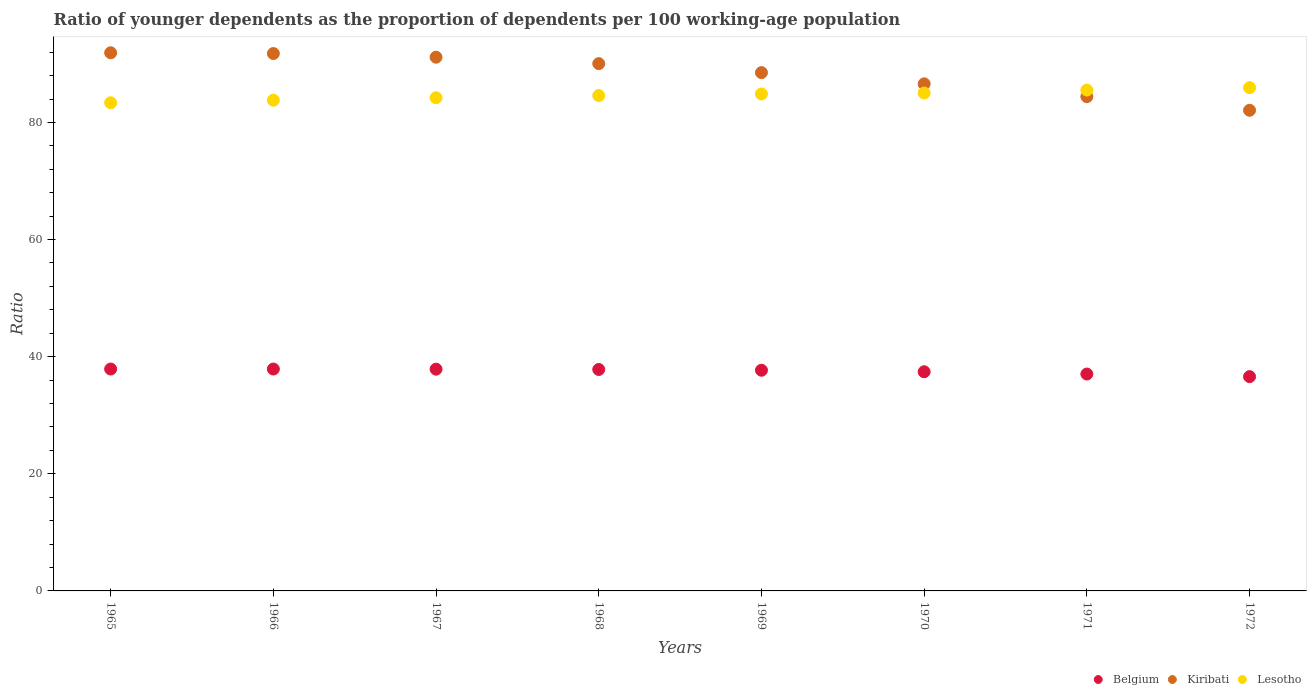What is the age dependency ratio(young) in Lesotho in 1965?
Give a very brief answer. 83.36. Across all years, what is the maximum age dependency ratio(young) in Belgium?
Offer a very short reply. 37.89. Across all years, what is the minimum age dependency ratio(young) in Kiribati?
Offer a very short reply. 82.08. In which year was the age dependency ratio(young) in Belgium maximum?
Give a very brief answer. 1966. In which year was the age dependency ratio(young) in Lesotho minimum?
Provide a short and direct response. 1965. What is the total age dependency ratio(young) in Lesotho in the graph?
Give a very brief answer. 677.34. What is the difference between the age dependency ratio(young) in Lesotho in 1966 and that in 1968?
Provide a short and direct response. -0.79. What is the difference between the age dependency ratio(young) in Belgium in 1966 and the age dependency ratio(young) in Kiribati in 1972?
Give a very brief answer. -44.19. What is the average age dependency ratio(young) in Belgium per year?
Your answer should be very brief. 37.53. In the year 1966, what is the difference between the age dependency ratio(young) in Lesotho and age dependency ratio(young) in Kiribati?
Your answer should be very brief. -7.97. In how many years, is the age dependency ratio(young) in Lesotho greater than 56?
Give a very brief answer. 8. What is the ratio of the age dependency ratio(young) in Kiribati in 1969 to that in 1971?
Your response must be concise. 1.05. Is the difference between the age dependency ratio(young) in Lesotho in 1966 and 1972 greater than the difference between the age dependency ratio(young) in Kiribati in 1966 and 1972?
Ensure brevity in your answer.  No. What is the difference between the highest and the second highest age dependency ratio(young) in Kiribati?
Provide a succinct answer. 0.13. What is the difference between the highest and the lowest age dependency ratio(young) in Kiribati?
Offer a terse response. 9.82. In how many years, is the age dependency ratio(young) in Lesotho greater than the average age dependency ratio(young) in Lesotho taken over all years?
Your answer should be compact. 4. Is the sum of the age dependency ratio(young) in Kiribati in 1967 and 1970 greater than the maximum age dependency ratio(young) in Lesotho across all years?
Provide a short and direct response. Yes. Is it the case that in every year, the sum of the age dependency ratio(young) in Belgium and age dependency ratio(young) in Kiribati  is greater than the age dependency ratio(young) in Lesotho?
Provide a succinct answer. Yes. Is the age dependency ratio(young) in Belgium strictly less than the age dependency ratio(young) in Kiribati over the years?
Ensure brevity in your answer.  Yes. How many years are there in the graph?
Ensure brevity in your answer.  8. What is the difference between two consecutive major ticks on the Y-axis?
Keep it short and to the point. 20. Are the values on the major ticks of Y-axis written in scientific E-notation?
Provide a succinct answer. No. Does the graph contain any zero values?
Your response must be concise. No. How many legend labels are there?
Provide a succinct answer. 3. How are the legend labels stacked?
Your answer should be compact. Horizontal. What is the title of the graph?
Your response must be concise. Ratio of younger dependents as the proportion of dependents per 100 working-age population. What is the label or title of the X-axis?
Offer a terse response. Years. What is the label or title of the Y-axis?
Your response must be concise. Ratio. What is the Ratio of Belgium in 1965?
Provide a succinct answer. 37.89. What is the Ratio of Kiribati in 1965?
Your answer should be compact. 91.9. What is the Ratio in Lesotho in 1965?
Ensure brevity in your answer.  83.36. What is the Ratio in Belgium in 1966?
Make the answer very short. 37.89. What is the Ratio of Kiribati in 1966?
Give a very brief answer. 91.77. What is the Ratio in Lesotho in 1966?
Provide a succinct answer. 83.8. What is the Ratio of Belgium in 1967?
Give a very brief answer. 37.87. What is the Ratio of Kiribati in 1967?
Make the answer very short. 91.14. What is the Ratio of Lesotho in 1967?
Provide a succinct answer. 84.22. What is the Ratio of Belgium in 1968?
Your response must be concise. 37.82. What is the Ratio in Kiribati in 1968?
Offer a very short reply. 90.04. What is the Ratio of Lesotho in 1968?
Give a very brief answer. 84.59. What is the Ratio in Belgium in 1969?
Give a very brief answer. 37.68. What is the Ratio of Kiribati in 1969?
Make the answer very short. 88.51. What is the Ratio in Lesotho in 1969?
Offer a terse response. 84.87. What is the Ratio of Belgium in 1970?
Give a very brief answer. 37.43. What is the Ratio of Kiribati in 1970?
Offer a terse response. 86.59. What is the Ratio of Lesotho in 1970?
Ensure brevity in your answer.  85.03. What is the Ratio of Belgium in 1971?
Offer a very short reply. 37.04. What is the Ratio of Kiribati in 1971?
Your answer should be very brief. 84.41. What is the Ratio in Lesotho in 1971?
Offer a terse response. 85.53. What is the Ratio of Belgium in 1972?
Ensure brevity in your answer.  36.59. What is the Ratio in Kiribati in 1972?
Offer a very short reply. 82.08. What is the Ratio of Lesotho in 1972?
Keep it short and to the point. 85.94. Across all years, what is the maximum Ratio in Belgium?
Your answer should be compact. 37.89. Across all years, what is the maximum Ratio of Kiribati?
Your answer should be very brief. 91.9. Across all years, what is the maximum Ratio of Lesotho?
Your answer should be very brief. 85.94. Across all years, what is the minimum Ratio in Belgium?
Keep it short and to the point. 36.59. Across all years, what is the minimum Ratio of Kiribati?
Keep it short and to the point. 82.08. Across all years, what is the minimum Ratio in Lesotho?
Your answer should be compact. 83.36. What is the total Ratio of Belgium in the graph?
Give a very brief answer. 300.2. What is the total Ratio of Kiribati in the graph?
Make the answer very short. 706.45. What is the total Ratio in Lesotho in the graph?
Make the answer very short. 677.34. What is the difference between the Ratio in Belgium in 1965 and that in 1966?
Your answer should be very brief. -0. What is the difference between the Ratio in Kiribati in 1965 and that in 1966?
Your answer should be very brief. 0.13. What is the difference between the Ratio in Lesotho in 1965 and that in 1966?
Offer a terse response. -0.44. What is the difference between the Ratio in Belgium in 1965 and that in 1967?
Your response must be concise. 0.02. What is the difference between the Ratio of Kiribati in 1965 and that in 1967?
Ensure brevity in your answer.  0.76. What is the difference between the Ratio in Lesotho in 1965 and that in 1967?
Your answer should be compact. -0.86. What is the difference between the Ratio of Belgium in 1965 and that in 1968?
Keep it short and to the point. 0.07. What is the difference between the Ratio of Kiribati in 1965 and that in 1968?
Provide a short and direct response. 1.86. What is the difference between the Ratio of Lesotho in 1965 and that in 1968?
Your answer should be compact. -1.23. What is the difference between the Ratio in Belgium in 1965 and that in 1969?
Offer a very short reply. 0.21. What is the difference between the Ratio in Kiribati in 1965 and that in 1969?
Your response must be concise. 3.39. What is the difference between the Ratio in Lesotho in 1965 and that in 1969?
Keep it short and to the point. -1.5. What is the difference between the Ratio of Belgium in 1965 and that in 1970?
Your answer should be very brief. 0.46. What is the difference between the Ratio in Kiribati in 1965 and that in 1970?
Provide a short and direct response. 5.3. What is the difference between the Ratio in Lesotho in 1965 and that in 1970?
Provide a short and direct response. -1.66. What is the difference between the Ratio in Belgium in 1965 and that in 1971?
Make the answer very short. 0.85. What is the difference between the Ratio of Kiribati in 1965 and that in 1971?
Provide a short and direct response. 7.49. What is the difference between the Ratio in Lesotho in 1965 and that in 1971?
Offer a very short reply. -2.17. What is the difference between the Ratio of Belgium in 1965 and that in 1972?
Offer a very short reply. 1.3. What is the difference between the Ratio in Kiribati in 1965 and that in 1972?
Provide a succinct answer. 9.82. What is the difference between the Ratio of Lesotho in 1965 and that in 1972?
Keep it short and to the point. -2.57. What is the difference between the Ratio in Belgium in 1966 and that in 1967?
Provide a short and direct response. 0.02. What is the difference between the Ratio in Kiribati in 1966 and that in 1967?
Give a very brief answer. 0.63. What is the difference between the Ratio of Lesotho in 1966 and that in 1967?
Make the answer very short. -0.42. What is the difference between the Ratio of Belgium in 1966 and that in 1968?
Offer a very short reply. 0.08. What is the difference between the Ratio of Kiribati in 1966 and that in 1968?
Offer a very short reply. 1.73. What is the difference between the Ratio in Lesotho in 1966 and that in 1968?
Offer a terse response. -0.79. What is the difference between the Ratio in Belgium in 1966 and that in 1969?
Give a very brief answer. 0.21. What is the difference between the Ratio in Kiribati in 1966 and that in 1969?
Ensure brevity in your answer.  3.26. What is the difference between the Ratio in Lesotho in 1966 and that in 1969?
Your answer should be very brief. -1.07. What is the difference between the Ratio in Belgium in 1966 and that in 1970?
Provide a succinct answer. 0.47. What is the difference between the Ratio in Kiribati in 1966 and that in 1970?
Provide a succinct answer. 5.17. What is the difference between the Ratio of Lesotho in 1966 and that in 1970?
Keep it short and to the point. -1.22. What is the difference between the Ratio of Belgium in 1966 and that in 1971?
Your answer should be very brief. 0.85. What is the difference between the Ratio in Kiribati in 1966 and that in 1971?
Ensure brevity in your answer.  7.36. What is the difference between the Ratio in Lesotho in 1966 and that in 1971?
Provide a short and direct response. -1.73. What is the difference between the Ratio of Kiribati in 1966 and that in 1972?
Offer a very short reply. 9.69. What is the difference between the Ratio in Lesotho in 1966 and that in 1972?
Your answer should be compact. -2.14. What is the difference between the Ratio in Belgium in 1967 and that in 1968?
Offer a terse response. 0.05. What is the difference between the Ratio of Kiribati in 1967 and that in 1968?
Offer a terse response. 1.1. What is the difference between the Ratio in Lesotho in 1967 and that in 1968?
Your response must be concise. -0.37. What is the difference between the Ratio of Belgium in 1967 and that in 1969?
Provide a short and direct response. 0.18. What is the difference between the Ratio of Kiribati in 1967 and that in 1969?
Give a very brief answer. 2.63. What is the difference between the Ratio in Lesotho in 1967 and that in 1969?
Provide a succinct answer. -0.65. What is the difference between the Ratio in Belgium in 1967 and that in 1970?
Offer a terse response. 0.44. What is the difference between the Ratio of Kiribati in 1967 and that in 1970?
Provide a succinct answer. 4.55. What is the difference between the Ratio of Lesotho in 1967 and that in 1970?
Your answer should be compact. -0.8. What is the difference between the Ratio of Belgium in 1967 and that in 1971?
Offer a terse response. 0.83. What is the difference between the Ratio of Kiribati in 1967 and that in 1971?
Keep it short and to the point. 6.73. What is the difference between the Ratio in Lesotho in 1967 and that in 1971?
Ensure brevity in your answer.  -1.31. What is the difference between the Ratio in Belgium in 1967 and that in 1972?
Your answer should be very brief. 1.28. What is the difference between the Ratio of Kiribati in 1967 and that in 1972?
Offer a terse response. 9.06. What is the difference between the Ratio of Lesotho in 1967 and that in 1972?
Ensure brevity in your answer.  -1.72. What is the difference between the Ratio in Belgium in 1968 and that in 1969?
Make the answer very short. 0.13. What is the difference between the Ratio in Kiribati in 1968 and that in 1969?
Offer a very short reply. 1.54. What is the difference between the Ratio in Lesotho in 1968 and that in 1969?
Your answer should be compact. -0.27. What is the difference between the Ratio of Belgium in 1968 and that in 1970?
Your answer should be compact. 0.39. What is the difference between the Ratio in Kiribati in 1968 and that in 1970?
Your answer should be very brief. 3.45. What is the difference between the Ratio in Lesotho in 1968 and that in 1970?
Give a very brief answer. -0.43. What is the difference between the Ratio in Belgium in 1968 and that in 1971?
Make the answer very short. 0.78. What is the difference between the Ratio in Kiribati in 1968 and that in 1971?
Offer a very short reply. 5.64. What is the difference between the Ratio of Lesotho in 1968 and that in 1971?
Your answer should be compact. -0.94. What is the difference between the Ratio in Belgium in 1968 and that in 1972?
Your answer should be compact. 1.22. What is the difference between the Ratio of Kiribati in 1968 and that in 1972?
Your answer should be compact. 7.97. What is the difference between the Ratio in Lesotho in 1968 and that in 1972?
Provide a short and direct response. -1.35. What is the difference between the Ratio of Belgium in 1969 and that in 1970?
Keep it short and to the point. 0.26. What is the difference between the Ratio of Kiribati in 1969 and that in 1970?
Ensure brevity in your answer.  1.91. What is the difference between the Ratio in Lesotho in 1969 and that in 1970?
Keep it short and to the point. -0.16. What is the difference between the Ratio of Belgium in 1969 and that in 1971?
Give a very brief answer. 0.64. What is the difference between the Ratio of Kiribati in 1969 and that in 1971?
Ensure brevity in your answer.  4.1. What is the difference between the Ratio of Lesotho in 1969 and that in 1971?
Keep it short and to the point. -0.67. What is the difference between the Ratio in Belgium in 1969 and that in 1972?
Keep it short and to the point. 1.09. What is the difference between the Ratio of Kiribati in 1969 and that in 1972?
Your response must be concise. 6.43. What is the difference between the Ratio of Lesotho in 1969 and that in 1972?
Give a very brief answer. -1.07. What is the difference between the Ratio of Belgium in 1970 and that in 1971?
Provide a succinct answer. 0.39. What is the difference between the Ratio in Kiribati in 1970 and that in 1971?
Your answer should be compact. 2.19. What is the difference between the Ratio in Lesotho in 1970 and that in 1971?
Your response must be concise. -0.51. What is the difference between the Ratio in Belgium in 1970 and that in 1972?
Offer a terse response. 0.83. What is the difference between the Ratio of Kiribati in 1970 and that in 1972?
Give a very brief answer. 4.52. What is the difference between the Ratio of Lesotho in 1970 and that in 1972?
Your response must be concise. -0.91. What is the difference between the Ratio in Belgium in 1971 and that in 1972?
Your answer should be very brief. 0.45. What is the difference between the Ratio in Kiribati in 1971 and that in 1972?
Your response must be concise. 2.33. What is the difference between the Ratio in Lesotho in 1971 and that in 1972?
Ensure brevity in your answer.  -0.41. What is the difference between the Ratio of Belgium in 1965 and the Ratio of Kiribati in 1966?
Give a very brief answer. -53.88. What is the difference between the Ratio in Belgium in 1965 and the Ratio in Lesotho in 1966?
Give a very brief answer. -45.91. What is the difference between the Ratio of Kiribati in 1965 and the Ratio of Lesotho in 1966?
Your answer should be very brief. 8.1. What is the difference between the Ratio of Belgium in 1965 and the Ratio of Kiribati in 1967?
Ensure brevity in your answer.  -53.25. What is the difference between the Ratio of Belgium in 1965 and the Ratio of Lesotho in 1967?
Provide a succinct answer. -46.33. What is the difference between the Ratio of Kiribati in 1965 and the Ratio of Lesotho in 1967?
Ensure brevity in your answer.  7.68. What is the difference between the Ratio in Belgium in 1965 and the Ratio in Kiribati in 1968?
Offer a very short reply. -52.15. What is the difference between the Ratio in Belgium in 1965 and the Ratio in Lesotho in 1968?
Offer a very short reply. -46.7. What is the difference between the Ratio in Kiribati in 1965 and the Ratio in Lesotho in 1968?
Your answer should be very brief. 7.31. What is the difference between the Ratio in Belgium in 1965 and the Ratio in Kiribati in 1969?
Provide a short and direct response. -50.62. What is the difference between the Ratio in Belgium in 1965 and the Ratio in Lesotho in 1969?
Your answer should be very brief. -46.98. What is the difference between the Ratio in Kiribati in 1965 and the Ratio in Lesotho in 1969?
Your answer should be very brief. 7.03. What is the difference between the Ratio of Belgium in 1965 and the Ratio of Kiribati in 1970?
Your answer should be very brief. -48.7. What is the difference between the Ratio in Belgium in 1965 and the Ratio in Lesotho in 1970?
Give a very brief answer. -47.14. What is the difference between the Ratio in Kiribati in 1965 and the Ratio in Lesotho in 1970?
Give a very brief answer. 6.87. What is the difference between the Ratio in Belgium in 1965 and the Ratio in Kiribati in 1971?
Offer a terse response. -46.52. What is the difference between the Ratio in Belgium in 1965 and the Ratio in Lesotho in 1971?
Keep it short and to the point. -47.64. What is the difference between the Ratio in Kiribati in 1965 and the Ratio in Lesotho in 1971?
Your answer should be compact. 6.37. What is the difference between the Ratio in Belgium in 1965 and the Ratio in Kiribati in 1972?
Offer a terse response. -44.19. What is the difference between the Ratio of Belgium in 1965 and the Ratio of Lesotho in 1972?
Provide a short and direct response. -48.05. What is the difference between the Ratio of Kiribati in 1965 and the Ratio of Lesotho in 1972?
Give a very brief answer. 5.96. What is the difference between the Ratio of Belgium in 1966 and the Ratio of Kiribati in 1967?
Provide a succinct answer. -53.25. What is the difference between the Ratio of Belgium in 1966 and the Ratio of Lesotho in 1967?
Offer a very short reply. -46.33. What is the difference between the Ratio in Kiribati in 1966 and the Ratio in Lesotho in 1967?
Your response must be concise. 7.55. What is the difference between the Ratio in Belgium in 1966 and the Ratio in Kiribati in 1968?
Offer a terse response. -52.15. What is the difference between the Ratio of Belgium in 1966 and the Ratio of Lesotho in 1968?
Ensure brevity in your answer.  -46.7. What is the difference between the Ratio of Kiribati in 1966 and the Ratio of Lesotho in 1968?
Keep it short and to the point. 7.18. What is the difference between the Ratio of Belgium in 1966 and the Ratio of Kiribati in 1969?
Keep it short and to the point. -50.62. What is the difference between the Ratio in Belgium in 1966 and the Ratio in Lesotho in 1969?
Provide a succinct answer. -46.97. What is the difference between the Ratio of Kiribati in 1966 and the Ratio of Lesotho in 1969?
Offer a terse response. 6.9. What is the difference between the Ratio in Belgium in 1966 and the Ratio in Kiribati in 1970?
Give a very brief answer. -48.7. What is the difference between the Ratio of Belgium in 1966 and the Ratio of Lesotho in 1970?
Ensure brevity in your answer.  -47.13. What is the difference between the Ratio in Kiribati in 1966 and the Ratio in Lesotho in 1970?
Give a very brief answer. 6.74. What is the difference between the Ratio of Belgium in 1966 and the Ratio of Kiribati in 1971?
Your response must be concise. -46.52. What is the difference between the Ratio of Belgium in 1966 and the Ratio of Lesotho in 1971?
Provide a succinct answer. -47.64. What is the difference between the Ratio of Kiribati in 1966 and the Ratio of Lesotho in 1971?
Your answer should be very brief. 6.24. What is the difference between the Ratio in Belgium in 1966 and the Ratio in Kiribati in 1972?
Keep it short and to the point. -44.19. What is the difference between the Ratio in Belgium in 1966 and the Ratio in Lesotho in 1972?
Offer a very short reply. -48.05. What is the difference between the Ratio of Kiribati in 1966 and the Ratio of Lesotho in 1972?
Offer a very short reply. 5.83. What is the difference between the Ratio in Belgium in 1967 and the Ratio in Kiribati in 1968?
Provide a succinct answer. -52.18. What is the difference between the Ratio in Belgium in 1967 and the Ratio in Lesotho in 1968?
Your answer should be compact. -46.72. What is the difference between the Ratio of Kiribati in 1967 and the Ratio of Lesotho in 1968?
Provide a short and direct response. 6.55. What is the difference between the Ratio of Belgium in 1967 and the Ratio of Kiribati in 1969?
Provide a short and direct response. -50.64. What is the difference between the Ratio of Belgium in 1967 and the Ratio of Lesotho in 1969?
Offer a very short reply. -47. What is the difference between the Ratio of Kiribati in 1967 and the Ratio of Lesotho in 1969?
Provide a short and direct response. 6.28. What is the difference between the Ratio of Belgium in 1967 and the Ratio of Kiribati in 1970?
Offer a terse response. -48.73. What is the difference between the Ratio in Belgium in 1967 and the Ratio in Lesotho in 1970?
Provide a succinct answer. -47.16. What is the difference between the Ratio of Kiribati in 1967 and the Ratio of Lesotho in 1970?
Ensure brevity in your answer.  6.12. What is the difference between the Ratio in Belgium in 1967 and the Ratio in Kiribati in 1971?
Make the answer very short. -46.54. What is the difference between the Ratio in Belgium in 1967 and the Ratio in Lesotho in 1971?
Make the answer very short. -47.67. What is the difference between the Ratio in Kiribati in 1967 and the Ratio in Lesotho in 1971?
Provide a succinct answer. 5.61. What is the difference between the Ratio in Belgium in 1967 and the Ratio in Kiribati in 1972?
Your response must be concise. -44.21. What is the difference between the Ratio in Belgium in 1967 and the Ratio in Lesotho in 1972?
Make the answer very short. -48.07. What is the difference between the Ratio of Kiribati in 1967 and the Ratio of Lesotho in 1972?
Your answer should be very brief. 5.2. What is the difference between the Ratio in Belgium in 1968 and the Ratio in Kiribati in 1969?
Your answer should be compact. -50.69. What is the difference between the Ratio of Belgium in 1968 and the Ratio of Lesotho in 1969?
Ensure brevity in your answer.  -47.05. What is the difference between the Ratio in Kiribati in 1968 and the Ratio in Lesotho in 1969?
Offer a terse response. 5.18. What is the difference between the Ratio in Belgium in 1968 and the Ratio in Kiribati in 1970?
Ensure brevity in your answer.  -48.78. What is the difference between the Ratio of Belgium in 1968 and the Ratio of Lesotho in 1970?
Your answer should be very brief. -47.21. What is the difference between the Ratio of Kiribati in 1968 and the Ratio of Lesotho in 1970?
Offer a terse response. 5.02. What is the difference between the Ratio of Belgium in 1968 and the Ratio of Kiribati in 1971?
Give a very brief answer. -46.59. What is the difference between the Ratio of Belgium in 1968 and the Ratio of Lesotho in 1971?
Offer a terse response. -47.72. What is the difference between the Ratio of Kiribati in 1968 and the Ratio of Lesotho in 1971?
Your answer should be very brief. 4.51. What is the difference between the Ratio in Belgium in 1968 and the Ratio in Kiribati in 1972?
Your answer should be very brief. -44.26. What is the difference between the Ratio of Belgium in 1968 and the Ratio of Lesotho in 1972?
Make the answer very short. -48.12. What is the difference between the Ratio in Kiribati in 1968 and the Ratio in Lesotho in 1972?
Make the answer very short. 4.11. What is the difference between the Ratio of Belgium in 1969 and the Ratio of Kiribati in 1970?
Give a very brief answer. -48.91. What is the difference between the Ratio of Belgium in 1969 and the Ratio of Lesotho in 1970?
Offer a terse response. -47.34. What is the difference between the Ratio in Kiribati in 1969 and the Ratio in Lesotho in 1970?
Provide a short and direct response. 3.48. What is the difference between the Ratio of Belgium in 1969 and the Ratio of Kiribati in 1971?
Your response must be concise. -46.73. What is the difference between the Ratio in Belgium in 1969 and the Ratio in Lesotho in 1971?
Provide a short and direct response. -47.85. What is the difference between the Ratio of Kiribati in 1969 and the Ratio of Lesotho in 1971?
Make the answer very short. 2.98. What is the difference between the Ratio in Belgium in 1969 and the Ratio in Kiribati in 1972?
Provide a succinct answer. -44.4. What is the difference between the Ratio of Belgium in 1969 and the Ratio of Lesotho in 1972?
Offer a terse response. -48.25. What is the difference between the Ratio in Kiribati in 1969 and the Ratio in Lesotho in 1972?
Your response must be concise. 2.57. What is the difference between the Ratio in Belgium in 1970 and the Ratio in Kiribati in 1971?
Your answer should be compact. -46.98. What is the difference between the Ratio in Belgium in 1970 and the Ratio in Lesotho in 1971?
Make the answer very short. -48.11. What is the difference between the Ratio in Kiribati in 1970 and the Ratio in Lesotho in 1971?
Offer a very short reply. 1.06. What is the difference between the Ratio in Belgium in 1970 and the Ratio in Kiribati in 1972?
Keep it short and to the point. -44.65. What is the difference between the Ratio in Belgium in 1970 and the Ratio in Lesotho in 1972?
Make the answer very short. -48.51. What is the difference between the Ratio in Kiribati in 1970 and the Ratio in Lesotho in 1972?
Offer a very short reply. 0.66. What is the difference between the Ratio in Belgium in 1971 and the Ratio in Kiribati in 1972?
Your response must be concise. -45.04. What is the difference between the Ratio of Belgium in 1971 and the Ratio of Lesotho in 1972?
Ensure brevity in your answer.  -48.9. What is the difference between the Ratio in Kiribati in 1971 and the Ratio in Lesotho in 1972?
Ensure brevity in your answer.  -1.53. What is the average Ratio in Belgium per year?
Offer a terse response. 37.53. What is the average Ratio of Kiribati per year?
Your answer should be very brief. 88.31. What is the average Ratio in Lesotho per year?
Make the answer very short. 84.67. In the year 1965, what is the difference between the Ratio in Belgium and Ratio in Kiribati?
Ensure brevity in your answer.  -54.01. In the year 1965, what is the difference between the Ratio in Belgium and Ratio in Lesotho?
Offer a terse response. -45.47. In the year 1965, what is the difference between the Ratio of Kiribati and Ratio of Lesotho?
Your answer should be very brief. 8.54. In the year 1966, what is the difference between the Ratio in Belgium and Ratio in Kiribati?
Make the answer very short. -53.88. In the year 1966, what is the difference between the Ratio of Belgium and Ratio of Lesotho?
Your answer should be very brief. -45.91. In the year 1966, what is the difference between the Ratio of Kiribati and Ratio of Lesotho?
Make the answer very short. 7.97. In the year 1967, what is the difference between the Ratio in Belgium and Ratio in Kiribati?
Your answer should be compact. -53.27. In the year 1967, what is the difference between the Ratio of Belgium and Ratio of Lesotho?
Ensure brevity in your answer.  -46.35. In the year 1967, what is the difference between the Ratio in Kiribati and Ratio in Lesotho?
Provide a succinct answer. 6.92. In the year 1968, what is the difference between the Ratio of Belgium and Ratio of Kiribati?
Provide a short and direct response. -52.23. In the year 1968, what is the difference between the Ratio of Belgium and Ratio of Lesotho?
Make the answer very short. -46.78. In the year 1968, what is the difference between the Ratio of Kiribati and Ratio of Lesotho?
Give a very brief answer. 5.45. In the year 1969, what is the difference between the Ratio in Belgium and Ratio in Kiribati?
Offer a very short reply. -50.82. In the year 1969, what is the difference between the Ratio in Belgium and Ratio in Lesotho?
Give a very brief answer. -47.18. In the year 1969, what is the difference between the Ratio in Kiribati and Ratio in Lesotho?
Ensure brevity in your answer.  3.64. In the year 1970, what is the difference between the Ratio in Belgium and Ratio in Kiribati?
Your response must be concise. -49.17. In the year 1970, what is the difference between the Ratio of Belgium and Ratio of Lesotho?
Ensure brevity in your answer.  -47.6. In the year 1970, what is the difference between the Ratio of Kiribati and Ratio of Lesotho?
Your answer should be compact. 1.57. In the year 1971, what is the difference between the Ratio in Belgium and Ratio in Kiribati?
Provide a short and direct response. -47.37. In the year 1971, what is the difference between the Ratio in Belgium and Ratio in Lesotho?
Your answer should be very brief. -48.49. In the year 1971, what is the difference between the Ratio of Kiribati and Ratio of Lesotho?
Make the answer very short. -1.12. In the year 1972, what is the difference between the Ratio of Belgium and Ratio of Kiribati?
Your answer should be compact. -45.49. In the year 1972, what is the difference between the Ratio of Belgium and Ratio of Lesotho?
Offer a very short reply. -49.35. In the year 1972, what is the difference between the Ratio in Kiribati and Ratio in Lesotho?
Give a very brief answer. -3.86. What is the ratio of the Ratio of Belgium in 1965 to that in 1966?
Provide a succinct answer. 1. What is the ratio of the Ratio of Lesotho in 1965 to that in 1966?
Your answer should be very brief. 0.99. What is the ratio of the Ratio of Kiribati in 1965 to that in 1967?
Keep it short and to the point. 1.01. What is the ratio of the Ratio of Belgium in 1965 to that in 1968?
Offer a terse response. 1. What is the ratio of the Ratio in Kiribati in 1965 to that in 1968?
Provide a succinct answer. 1.02. What is the ratio of the Ratio in Lesotho in 1965 to that in 1968?
Your answer should be very brief. 0.99. What is the ratio of the Ratio of Kiribati in 1965 to that in 1969?
Your answer should be compact. 1.04. What is the ratio of the Ratio of Lesotho in 1965 to that in 1969?
Provide a short and direct response. 0.98. What is the ratio of the Ratio of Belgium in 1965 to that in 1970?
Provide a short and direct response. 1.01. What is the ratio of the Ratio of Kiribati in 1965 to that in 1970?
Offer a very short reply. 1.06. What is the ratio of the Ratio in Lesotho in 1965 to that in 1970?
Make the answer very short. 0.98. What is the ratio of the Ratio in Kiribati in 1965 to that in 1971?
Offer a very short reply. 1.09. What is the ratio of the Ratio of Lesotho in 1965 to that in 1971?
Your answer should be very brief. 0.97. What is the ratio of the Ratio in Belgium in 1965 to that in 1972?
Your answer should be compact. 1.04. What is the ratio of the Ratio in Kiribati in 1965 to that in 1972?
Provide a short and direct response. 1.12. What is the ratio of the Ratio of Lesotho in 1965 to that in 1972?
Ensure brevity in your answer.  0.97. What is the ratio of the Ratio in Belgium in 1966 to that in 1967?
Your answer should be very brief. 1. What is the ratio of the Ratio in Kiribati in 1966 to that in 1967?
Keep it short and to the point. 1.01. What is the ratio of the Ratio of Kiribati in 1966 to that in 1968?
Keep it short and to the point. 1.02. What is the ratio of the Ratio of Lesotho in 1966 to that in 1968?
Provide a succinct answer. 0.99. What is the ratio of the Ratio of Belgium in 1966 to that in 1969?
Your response must be concise. 1.01. What is the ratio of the Ratio of Kiribati in 1966 to that in 1969?
Make the answer very short. 1.04. What is the ratio of the Ratio in Lesotho in 1966 to that in 1969?
Your response must be concise. 0.99. What is the ratio of the Ratio of Belgium in 1966 to that in 1970?
Keep it short and to the point. 1.01. What is the ratio of the Ratio in Kiribati in 1966 to that in 1970?
Your answer should be compact. 1.06. What is the ratio of the Ratio in Lesotho in 1966 to that in 1970?
Your answer should be very brief. 0.99. What is the ratio of the Ratio of Belgium in 1966 to that in 1971?
Your response must be concise. 1.02. What is the ratio of the Ratio of Kiribati in 1966 to that in 1971?
Offer a very short reply. 1.09. What is the ratio of the Ratio of Lesotho in 1966 to that in 1971?
Give a very brief answer. 0.98. What is the ratio of the Ratio in Belgium in 1966 to that in 1972?
Offer a terse response. 1.04. What is the ratio of the Ratio of Kiribati in 1966 to that in 1972?
Provide a succinct answer. 1.12. What is the ratio of the Ratio of Lesotho in 1966 to that in 1972?
Offer a very short reply. 0.98. What is the ratio of the Ratio of Belgium in 1967 to that in 1968?
Keep it short and to the point. 1. What is the ratio of the Ratio of Kiribati in 1967 to that in 1968?
Offer a very short reply. 1.01. What is the ratio of the Ratio of Belgium in 1967 to that in 1969?
Keep it short and to the point. 1. What is the ratio of the Ratio in Kiribati in 1967 to that in 1969?
Make the answer very short. 1.03. What is the ratio of the Ratio of Belgium in 1967 to that in 1970?
Provide a succinct answer. 1.01. What is the ratio of the Ratio in Kiribati in 1967 to that in 1970?
Your answer should be very brief. 1.05. What is the ratio of the Ratio of Lesotho in 1967 to that in 1970?
Your response must be concise. 0.99. What is the ratio of the Ratio in Belgium in 1967 to that in 1971?
Your answer should be very brief. 1.02. What is the ratio of the Ratio of Kiribati in 1967 to that in 1971?
Provide a succinct answer. 1.08. What is the ratio of the Ratio of Lesotho in 1967 to that in 1971?
Your answer should be compact. 0.98. What is the ratio of the Ratio of Belgium in 1967 to that in 1972?
Ensure brevity in your answer.  1.03. What is the ratio of the Ratio of Kiribati in 1967 to that in 1972?
Make the answer very short. 1.11. What is the ratio of the Ratio of Lesotho in 1967 to that in 1972?
Provide a short and direct response. 0.98. What is the ratio of the Ratio of Kiribati in 1968 to that in 1969?
Offer a terse response. 1.02. What is the ratio of the Ratio in Belgium in 1968 to that in 1970?
Offer a terse response. 1.01. What is the ratio of the Ratio of Kiribati in 1968 to that in 1970?
Your answer should be compact. 1.04. What is the ratio of the Ratio in Lesotho in 1968 to that in 1970?
Provide a short and direct response. 0.99. What is the ratio of the Ratio of Belgium in 1968 to that in 1971?
Your answer should be very brief. 1.02. What is the ratio of the Ratio in Kiribati in 1968 to that in 1971?
Your answer should be compact. 1.07. What is the ratio of the Ratio in Lesotho in 1968 to that in 1971?
Keep it short and to the point. 0.99. What is the ratio of the Ratio in Belgium in 1968 to that in 1972?
Provide a short and direct response. 1.03. What is the ratio of the Ratio of Kiribati in 1968 to that in 1972?
Make the answer very short. 1.1. What is the ratio of the Ratio of Lesotho in 1968 to that in 1972?
Offer a terse response. 0.98. What is the ratio of the Ratio of Belgium in 1969 to that in 1970?
Your answer should be very brief. 1.01. What is the ratio of the Ratio in Kiribati in 1969 to that in 1970?
Give a very brief answer. 1.02. What is the ratio of the Ratio of Lesotho in 1969 to that in 1970?
Your response must be concise. 1. What is the ratio of the Ratio in Belgium in 1969 to that in 1971?
Provide a succinct answer. 1.02. What is the ratio of the Ratio of Kiribati in 1969 to that in 1971?
Ensure brevity in your answer.  1.05. What is the ratio of the Ratio in Belgium in 1969 to that in 1972?
Make the answer very short. 1.03. What is the ratio of the Ratio in Kiribati in 1969 to that in 1972?
Keep it short and to the point. 1.08. What is the ratio of the Ratio in Lesotho in 1969 to that in 1972?
Offer a terse response. 0.99. What is the ratio of the Ratio of Belgium in 1970 to that in 1971?
Your answer should be very brief. 1.01. What is the ratio of the Ratio of Kiribati in 1970 to that in 1971?
Make the answer very short. 1.03. What is the ratio of the Ratio of Lesotho in 1970 to that in 1971?
Provide a short and direct response. 0.99. What is the ratio of the Ratio in Belgium in 1970 to that in 1972?
Offer a very short reply. 1.02. What is the ratio of the Ratio in Kiribati in 1970 to that in 1972?
Give a very brief answer. 1.05. What is the ratio of the Ratio of Belgium in 1971 to that in 1972?
Your answer should be compact. 1.01. What is the ratio of the Ratio of Kiribati in 1971 to that in 1972?
Ensure brevity in your answer.  1.03. What is the difference between the highest and the second highest Ratio of Belgium?
Give a very brief answer. 0. What is the difference between the highest and the second highest Ratio in Kiribati?
Your response must be concise. 0.13. What is the difference between the highest and the second highest Ratio of Lesotho?
Your answer should be compact. 0.41. What is the difference between the highest and the lowest Ratio of Belgium?
Give a very brief answer. 1.3. What is the difference between the highest and the lowest Ratio in Kiribati?
Offer a very short reply. 9.82. What is the difference between the highest and the lowest Ratio in Lesotho?
Your response must be concise. 2.57. 